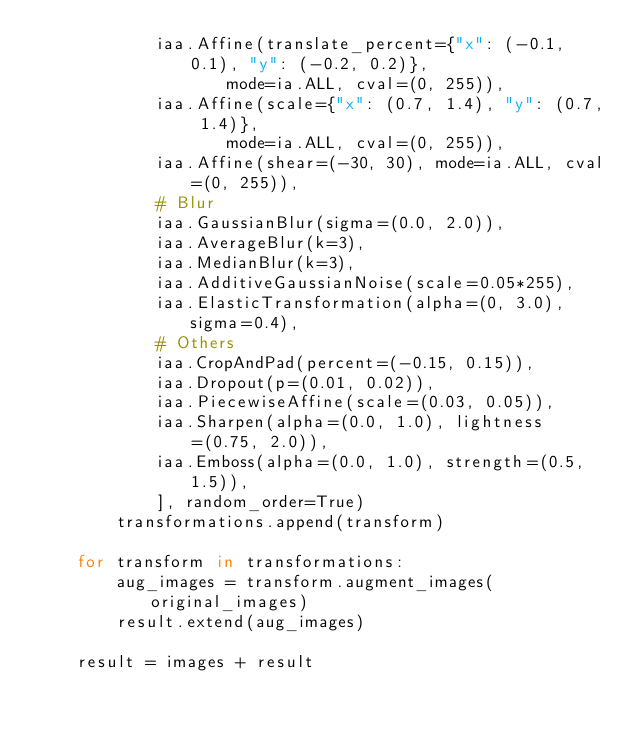<code> <loc_0><loc_0><loc_500><loc_500><_Python_>            iaa.Affine(translate_percent={"x": (-0.1, 0.1), "y": (-0.2, 0.2)},
                   mode=ia.ALL, cval=(0, 255)),
            iaa.Affine(scale={"x": (0.7, 1.4), "y": (0.7, 1.4)},
                   mode=ia.ALL, cval=(0, 255)),
            iaa.Affine(shear=(-30, 30), mode=ia.ALL, cval=(0, 255)),
            # Blur
            iaa.GaussianBlur(sigma=(0.0, 2.0)),
            iaa.AverageBlur(k=3),
            iaa.MedianBlur(k=3),
            iaa.AdditiveGaussianNoise(scale=0.05*255),
            iaa.ElasticTransformation(alpha=(0, 3.0), sigma=0.4), 
            # Others
            iaa.CropAndPad(percent=(-0.15, 0.15)),
            iaa.Dropout(p=(0.01, 0.02)),
            iaa.PiecewiseAffine(scale=(0.03, 0.05)),
            iaa.Sharpen(alpha=(0.0, 1.0), lightness=(0.75, 2.0)),
            iaa.Emboss(alpha=(0.0, 1.0), strength=(0.5, 1.5)),
            ], random_order=True)
        transformations.append(transform)
    
    for transform in transformations:
        aug_images = transform.augment_images(original_images)
        result.extend(aug_images)

    result = images + result </code> 